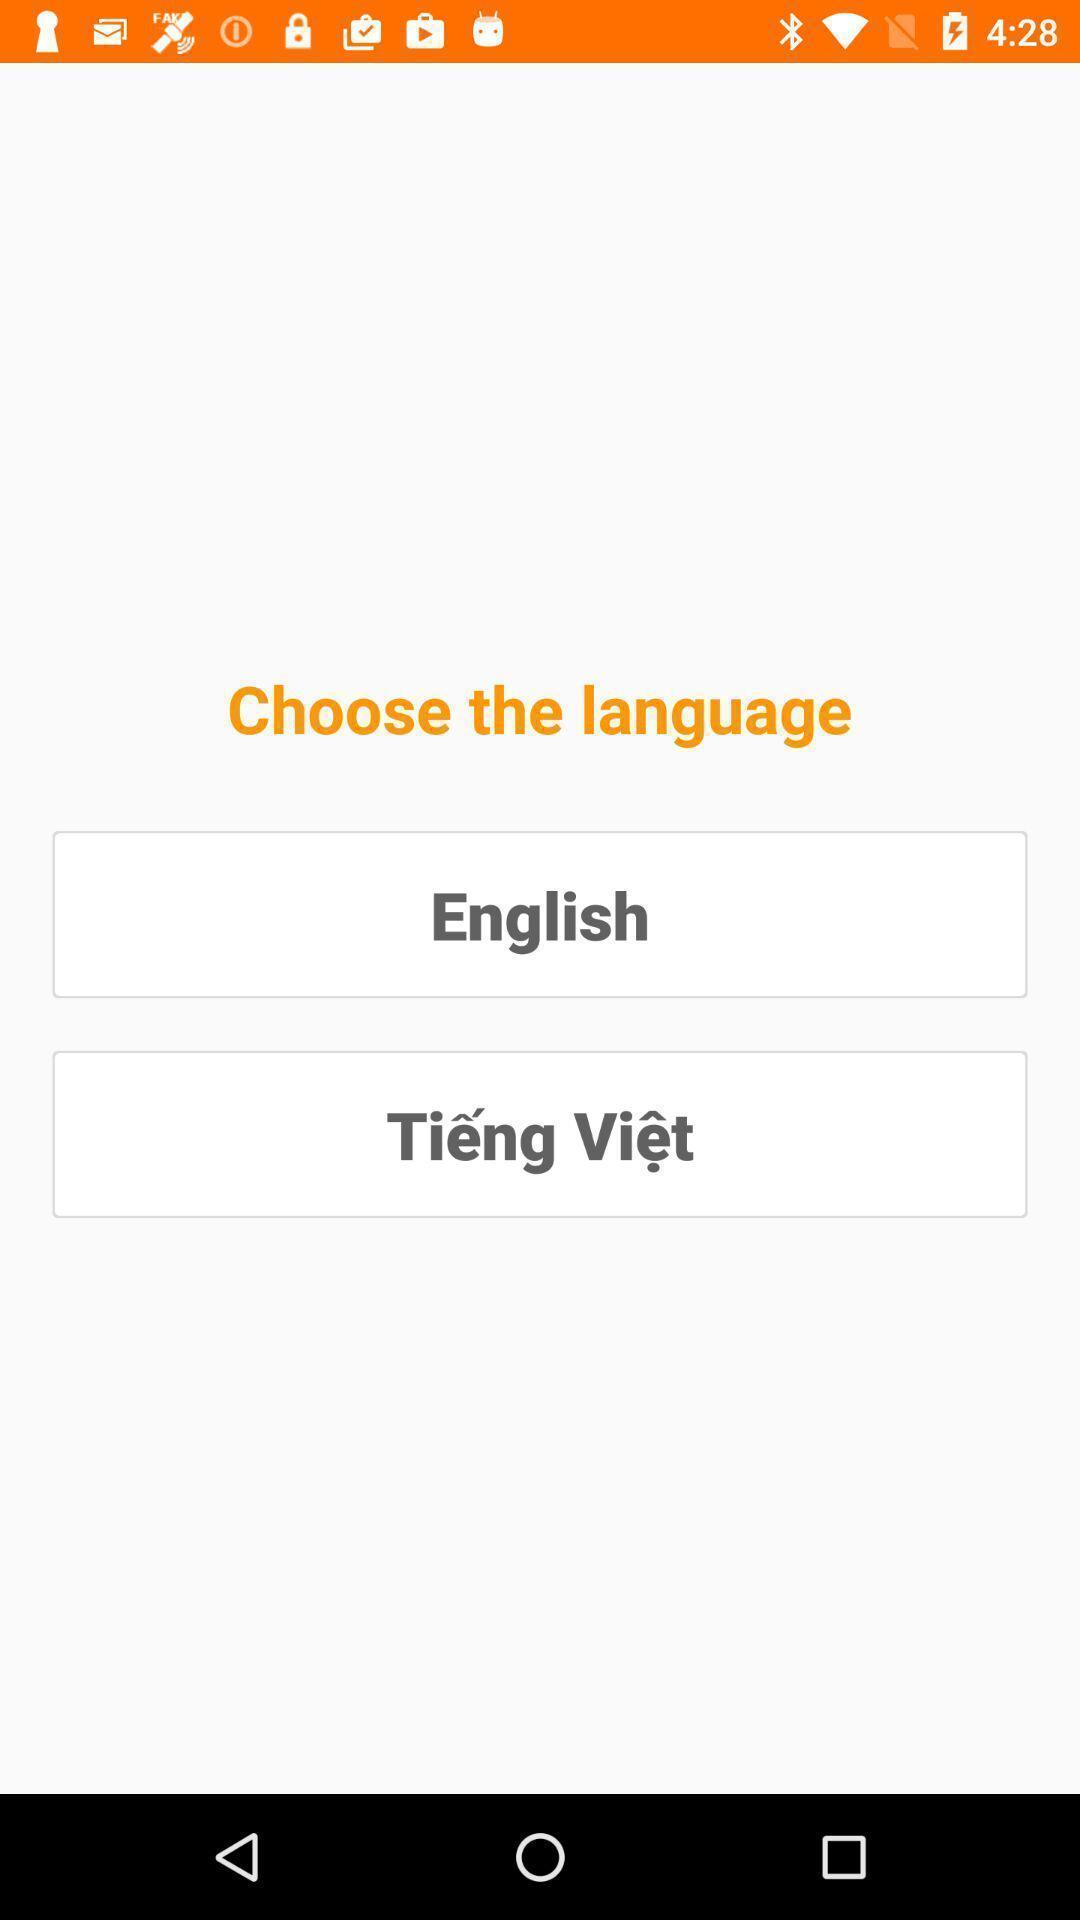What details can you identify in this image? Page shows to select a language. 